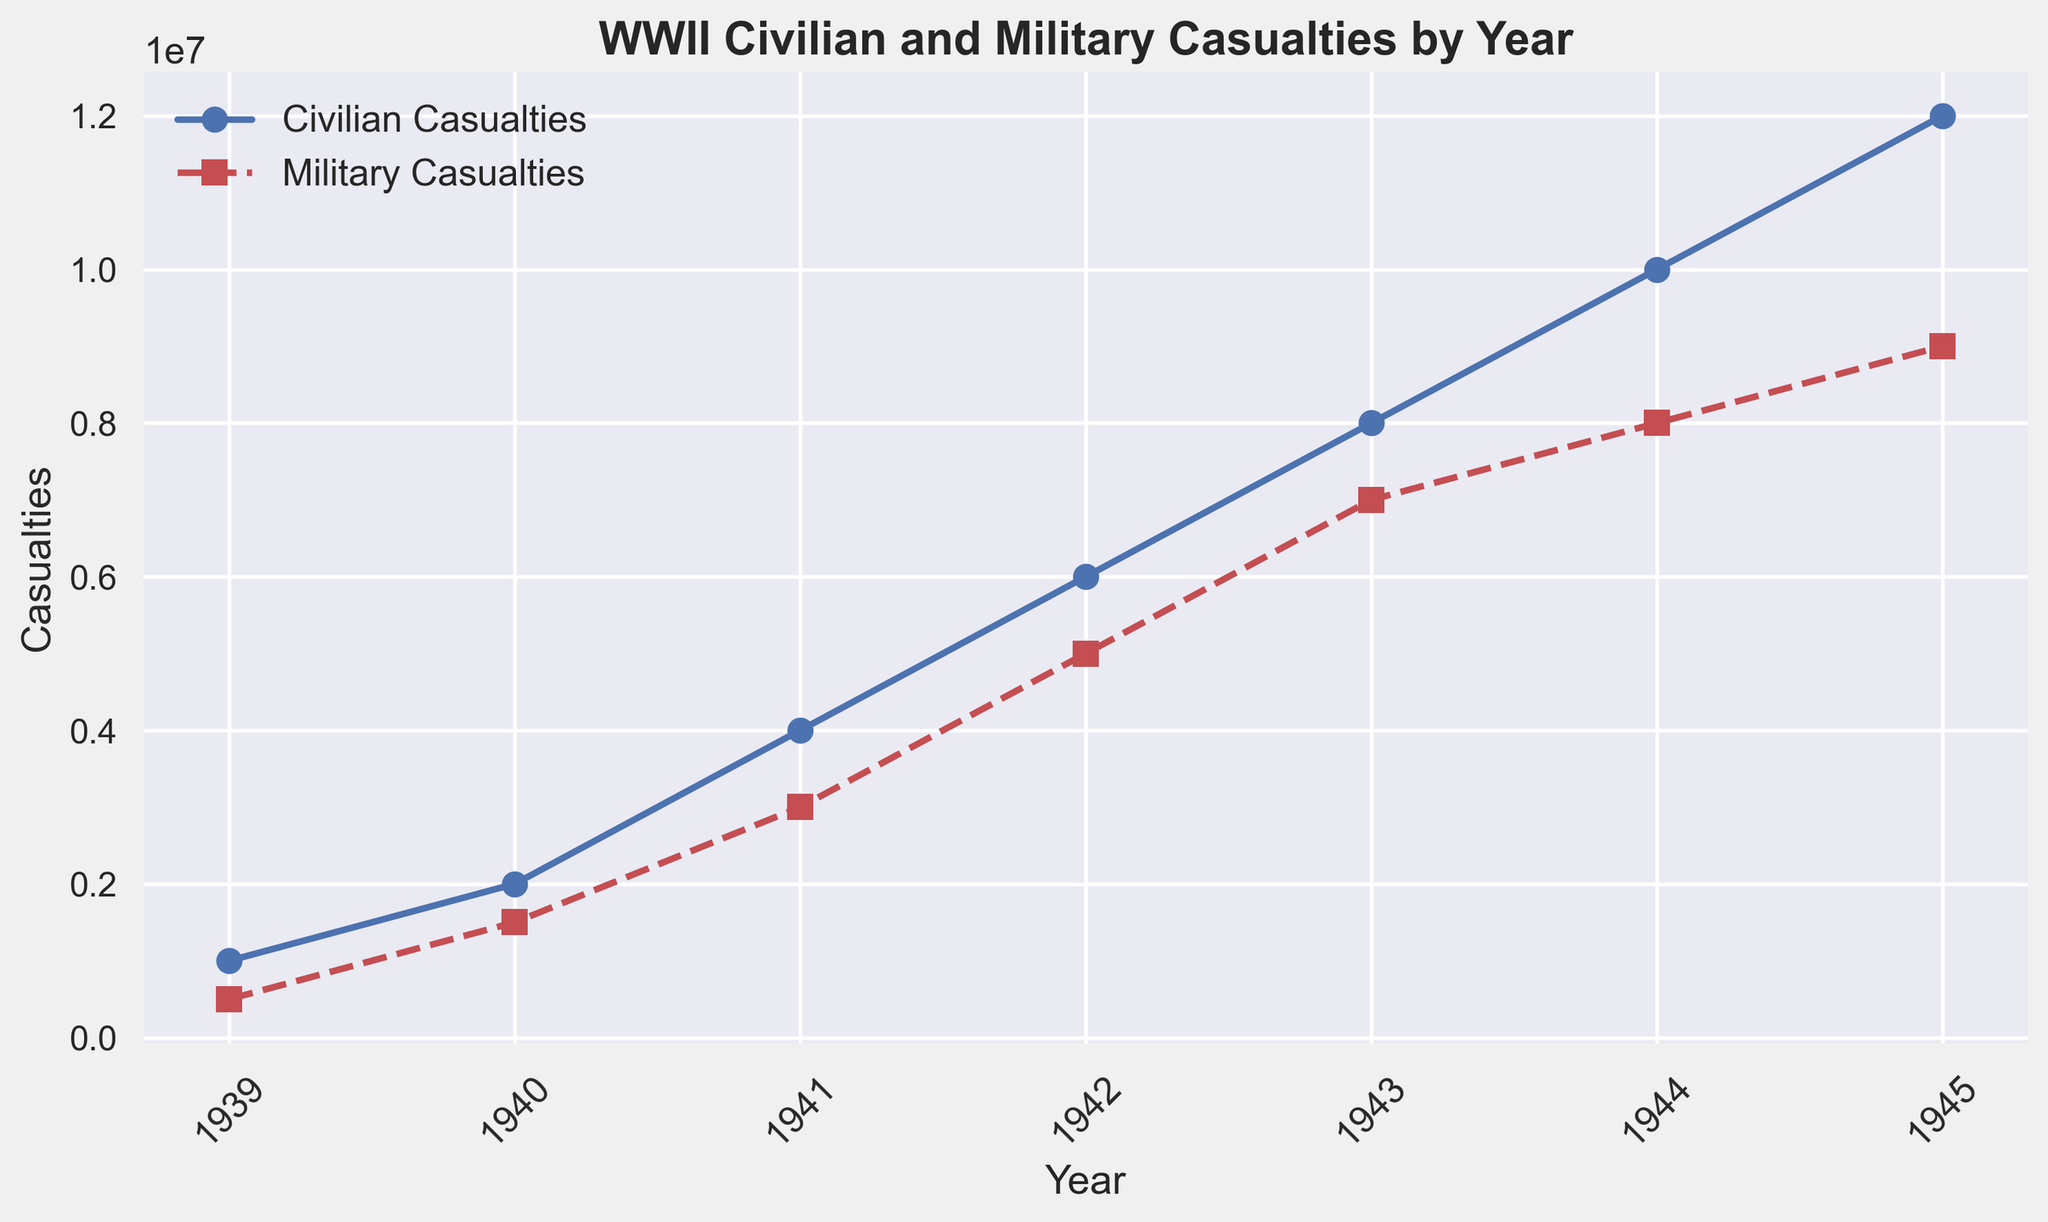What is the total number of casualties (civilian and military) in the year 1942? To find the total number of casualties in 1942, sum the number of civilian casualties and military casualties for that year. Based on the chart, in 1942, there were 6,000,000 civilian casualties and 5,000,000 military casualties. So, 6,000,000 + 5,000,000 = 11,000,000.
Answer: 11,000,000 Between which two consecutive years was the increase in military casualties the greatest? To determine the greatest increase, look at the differences in military casualties between consecutive years. The differences are: 1939-1940 (1,500,000 - 500,000 = 1,000,000), 1940-1941 (3,000,000 - 1,500,000 = 1,500,000), 1941-1942 (5,000,000 - 3,000,000 = 2,000,000), 1942-1943 (7,000,000 - 5,000,000 = 2,000,000), 1943-1944 (8,000,000 - 7,000,000 = 1,000,000), 1944-1945 (9,000,000 - 8,000,000 = 1,000,000). The highest increase is 2,000,000, which occurred between 1941-1942 and 1942-1943.
Answer: 1941 and 1942 How many years did it take for military casualties to reach 9,000,000? Start counting from the initial year 1939, where military casualties were 500,000. The military casualties reached 9,000,000 in 1945. So, from 1939 to 1945, it is a span of 1945 - 1939 = 6 years.
Answer: 6 years Which year saw the smallest difference between civilian and military casualties? Calculate the difference between civilian and military casualties for each year. The differences are: 1939 (1,000,000 - 500,000 = 500,000), 1940 (2,000,000 - 1,500,000 = 500,000), 1941 (4,000,000 - 3,000,000 = 1,000,000), 1942 (6,000,000 - 5,000,000 = 1,000,000), 1943 (8,000,000 - 7,000,000 = 1,000,000), 1944 (10,000,000 - 8,000,000 = 2,000,000), 1945 (12,000,000 - 9,000,000 = 3,000,000). The smallest difference is 500,000, occurring in 1939 and 1940.
Answer: 1939 and 1940 During which year did civilian casualties first surpass 10,000,000? Looking at the chart, we see that civilian casualties surpassed 10,000,000 in 1944, where the number of civilian casualties reached 10,000,000.
Answer: 1944 In which year did the increase in civilian casualties stop accelerating, as indicated by the line plot's slope? Check the slope of the line plot for civilian casualties. Up until 1944, the slope appears to increase. From 1944 to 1945, the slope is consistent with the previous year's slope. Therefore, it indicates that the increase in civilian casualties stopped accelerating in 1944.
Answer: 1944 By how much did civilian casualties exceed military casualties in 1945? In 1945, civilian casualties were 12,000,000, and military casualties were 9,000,000. The difference is 12,000,000 - 9,000,000 = 3,000,000.
Answer: 3,000,000 Which indicator (civilian or military casualties) showed a more significant relative increase between 1939 and 1945? Calculate the relative increase for both indicators from 1939 to 1945. For civilian casualties, (12,000,000 - 1,000,000) / 1,000,000 = 11. For military casualties, (9,000,000 - 500,000) / 500,000 = 17. The military casualties increased by a factor of 17, while civilian casualties increased by a factor of 11. Thus, military casualties showed a more significant relative increase.
Answer: Military Casualties 